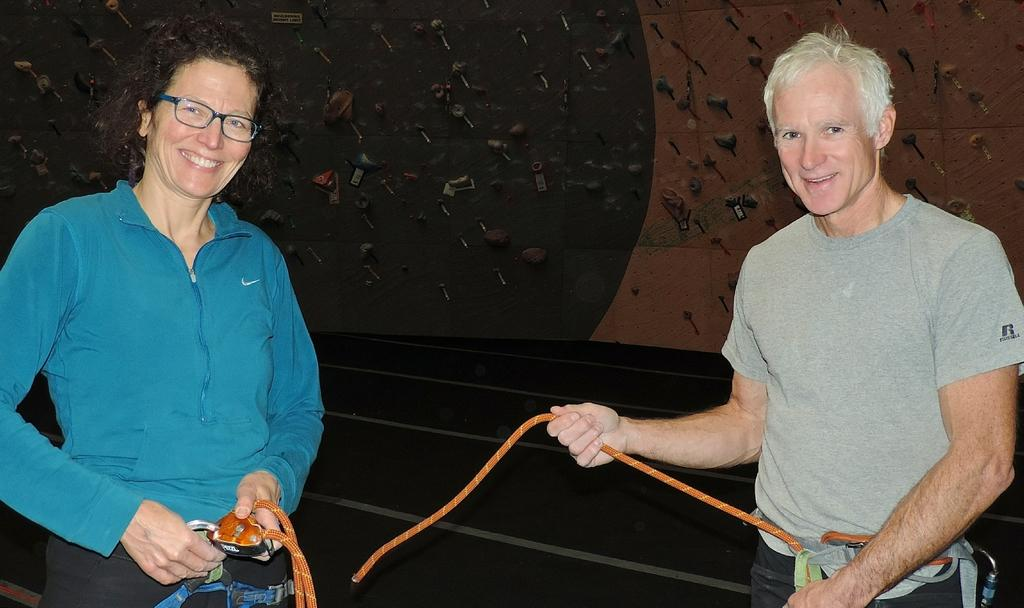How many people are in the image? There are two people in the image, a man and a woman. What are the man and woman doing in the image? The man and woman are standing. Can you describe the woman's appearance in the image? The woman is wearing spectacles. What else can be seen in the image besides the man and woman? There is a rope and a floor in the image. How many dolls are sitting on the rope in the image? There are no dolls present in the image, and the rope is not being used to support any dolls. 